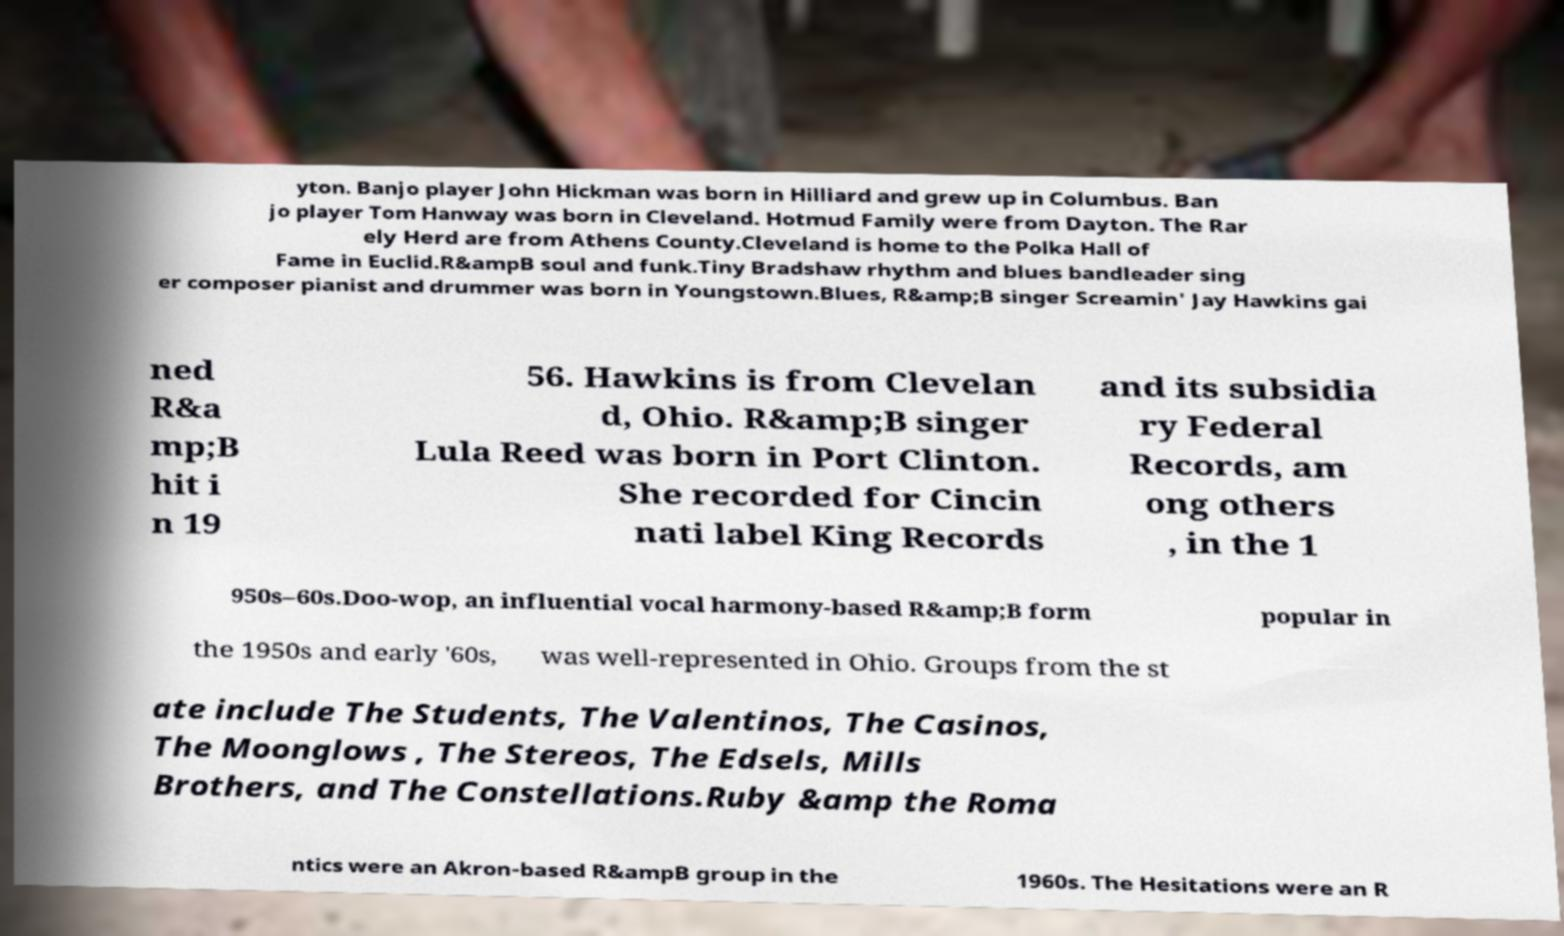I need the written content from this picture converted into text. Can you do that? yton. Banjo player John Hickman was born in Hilliard and grew up in Columbus. Ban jo player Tom Hanway was born in Cleveland. Hotmud Family were from Dayton. The Rar ely Herd are from Athens County.Cleveland is home to the Polka Hall of Fame in Euclid.R&ampB soul and funk.Tiny Bradshaw rhythm and blues bandleader sing er composer pianist and drummer was born in Youngstown.Blues, R&amp;B singer Screamin' Jay Hawkins gai ned R&a mp;B hit i n 19 56. Hawkins is from Clevelan d, Ohio. R&amp;B singer Lula Reed was born in Port Clinton. She recorded for Cincin nati label King Records and its subsidia ry Federal Records, am ong others , in the 1 950s–60s.Doo-wop, an influential vocal harmony-based R&amp;B form popular in the 1950s and early '60s, was well-represented in Ohio. Groups from the st ate include The Students, The Valentinos, The Casinos, The Moonglows , The Stereos, The Edsels, Mills Brothers, and The Constellations.Ruby &amp the Roma ntics were an Akron-based R&ampB group in the 1960s. The Hesitations were an R 